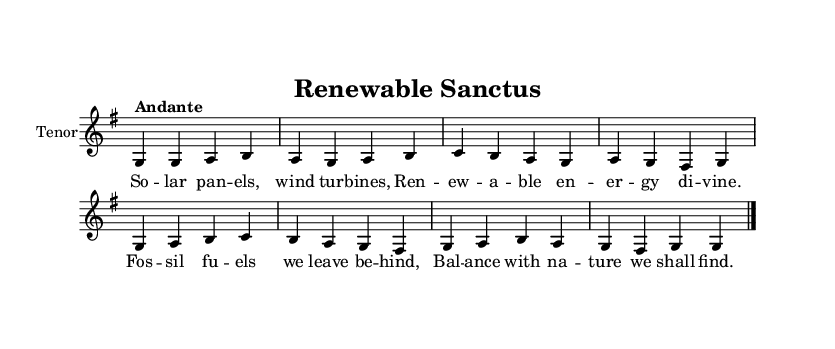What is the key signature of this music? The key signature is indicated at the beginning of the score, showing one sharp, which corresponds to G major.
Answer: G major What is the time signature of this music? The time signature appears near the beginning of the score, represented as a fraction, and it is 4/4, indicating four beats per measure.
Answer: 4/4 What is the tempo marking of this music? The tempo marking is noted as "Andante" in the score, which suggests a moderate pace.
Answer: Andante How many measures are in the melody? By counting the groups of bar lines within the melody section, there are eight measures written out.
Answer: Eight What is the first word of the lyrics? The lyrics start with the word indicated on the first note of the melody, which is "So."
Answer: So What theme is expressed in the lyrics of this chant? The lyrics combine themes of renewable energy and ecological balance, expressing a commitment to nature and sustainability.
Answer: Renewable energy and ecological balance What is the final note of the melody? The final note in the melody section is indicated just before the closing bar line, which is a G note.
Answer: G 